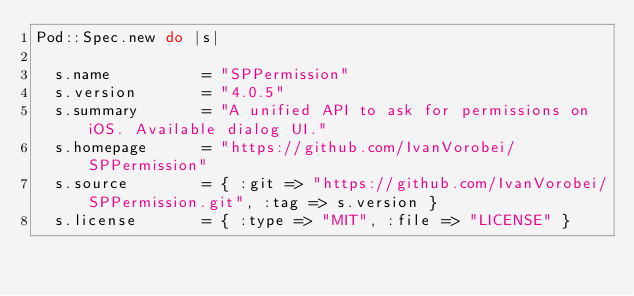<code> <loc_0><loc_0><loc_500><loc_500><_Ruby_>Pod::Spec.new do |s|

  s.name          = "SPPermission"
  s.version       = "4.0.5"
  s.summary       = "A unified API to ask for permissions on iOS. Available dialog UI."
  s.homepage      = "https://github.com/IvanVorobei/SPPermission"
  s.source        = { :git => "https://github.com/IvanVorobei/SPPermission.git", :tag => s.version }
  s.license       = { :type => "MIT", :file => "LICENSE" }
  </code> 